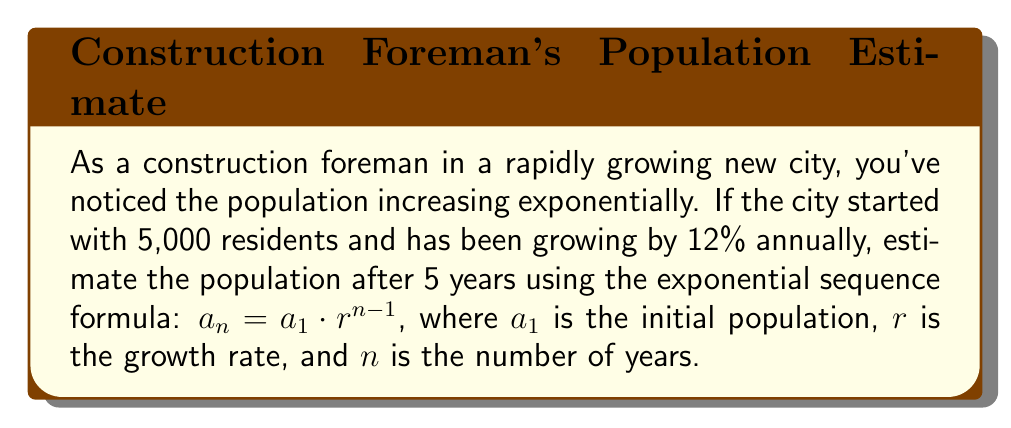Teach me how to tackle this problem. Let's approach this step-by-step:

1) We're given:
   $a_1 = 5,000$ (initial population)
   $r = 1.12$ (growth rate of 12% = 1 + 0.12)
   $n = 5$ (number of years)

2) We'll use the formula: $a_n = a_1 \cdot r^{n-1}$

3) Substituting our values:
   $a_5 = 5,000 \cdot (1.12)^{5-1}$

4) Simplify the exponent:
   $a_5 = 5,000 \cdot (1.12)^4$

5) Calculate $(1.12)^4$:
   $(1.12)^4 \approx 1.5735$ (rounded to 4 decimal places)

6) Multiply:
   $a_5 = 5,000 \cdot 1.5735 = 7,867.5$

7) Since we're estimating population, we'll round to the nearest whole number:
   $a_5 \approx 7,868$

Therefore, the estimated population after 5 years is approximately 7,868 residents.
Answer: 7,868 residents 